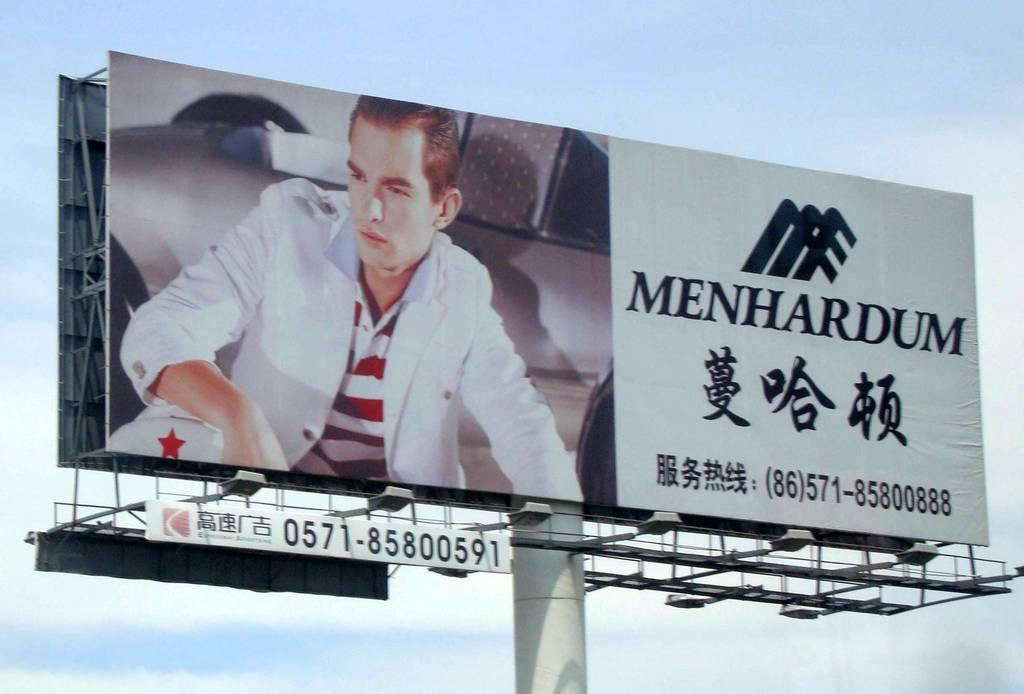What is the main subject in the middle of the picture? There is an advertising flex in the middle of the picture. What can be seen in the background of the image? The background of the image includes the sky. What type of spark can be seen exchanged between the clouds in the image? There is no spark present in the image, and the clouds are not exchanging anything. 